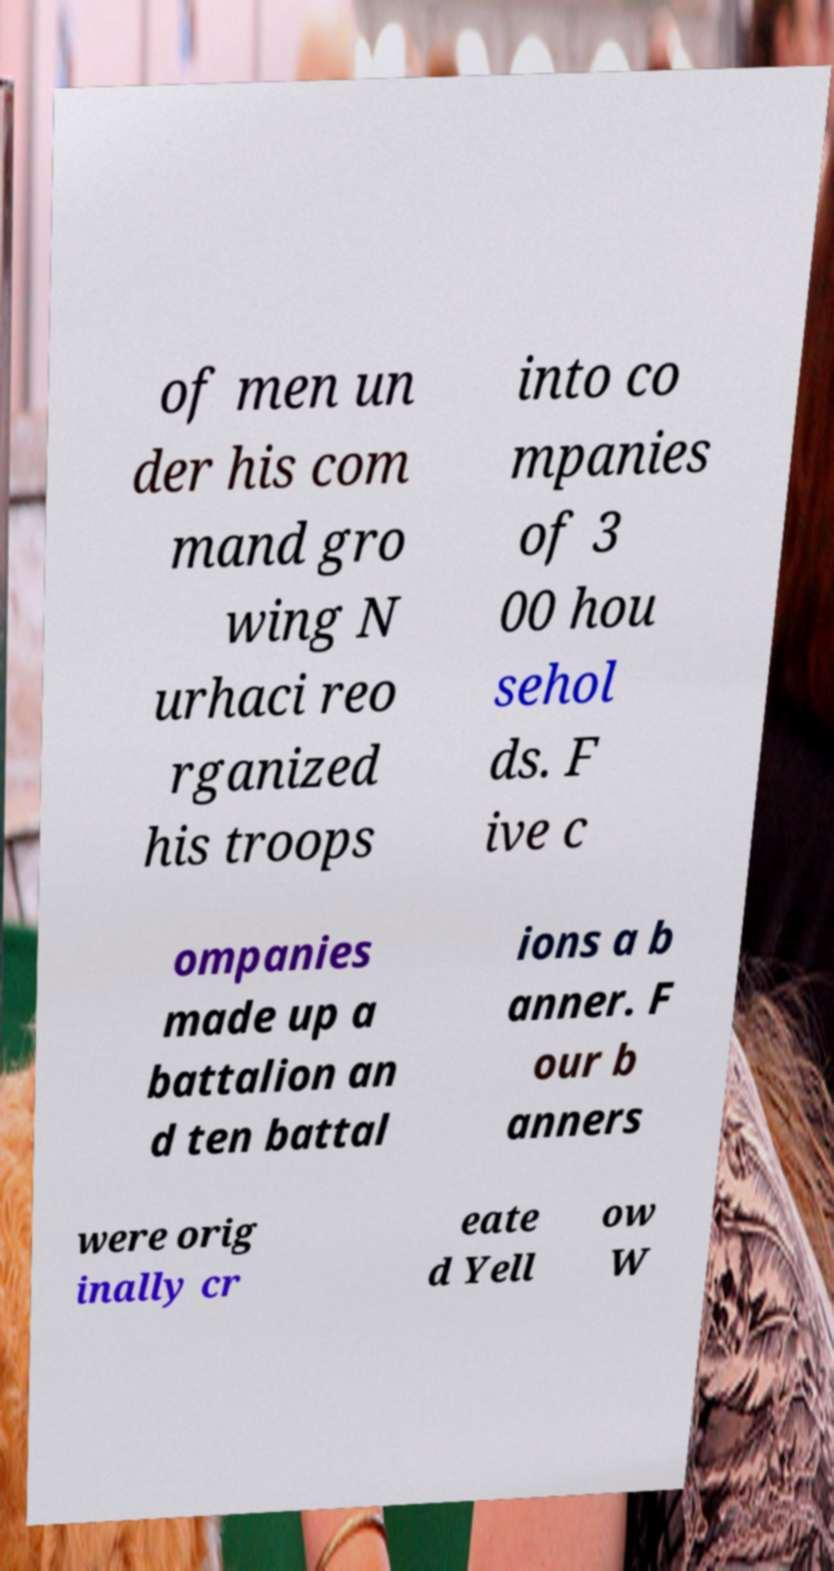There's text embedded in this image that I need extracted. Can you transcribe it verbatim? of men un der his com mand gro wing N urhaci reo rganized his troops into co mpanies of 3 00 hou sehol ds. F ive c ompanies made up a battalion an d ten battal ions a b anner. F our b anners were orig inally cr eate d Yell ow W 